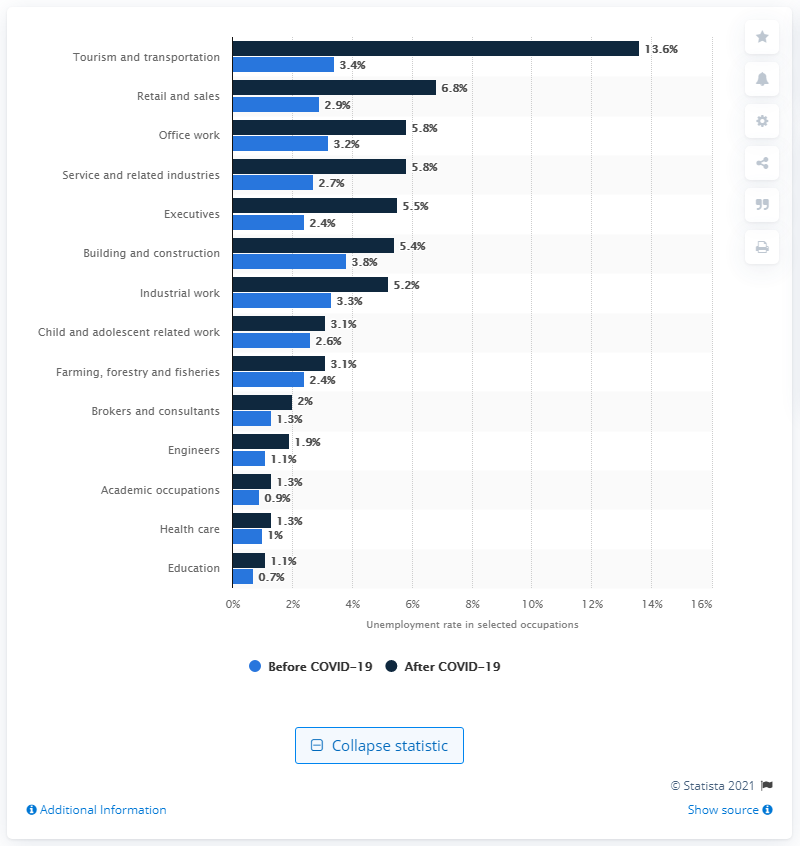Highlight a few significant elements in this photo. As of February 2021, the unemployment rate in the tourism and transportation sector was 13.6%. Before the COVID-19 pandemic, the unemployment rate in the tourism and transportation sector was 3.4%. 